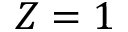<formula> <loc_0><loc_0><loc_500><loc_500>Z = 1</formula> 